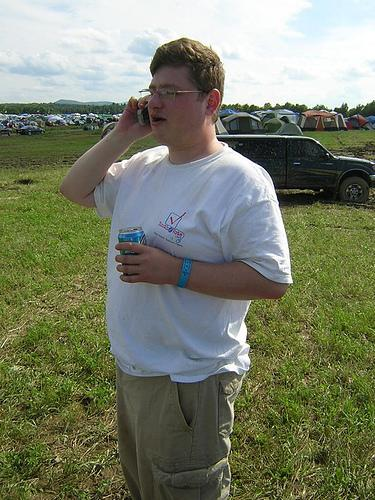Where will people located here sleep tonight?

Choices:
A) no where
B) tents
C) limos
D) duplexes tents 